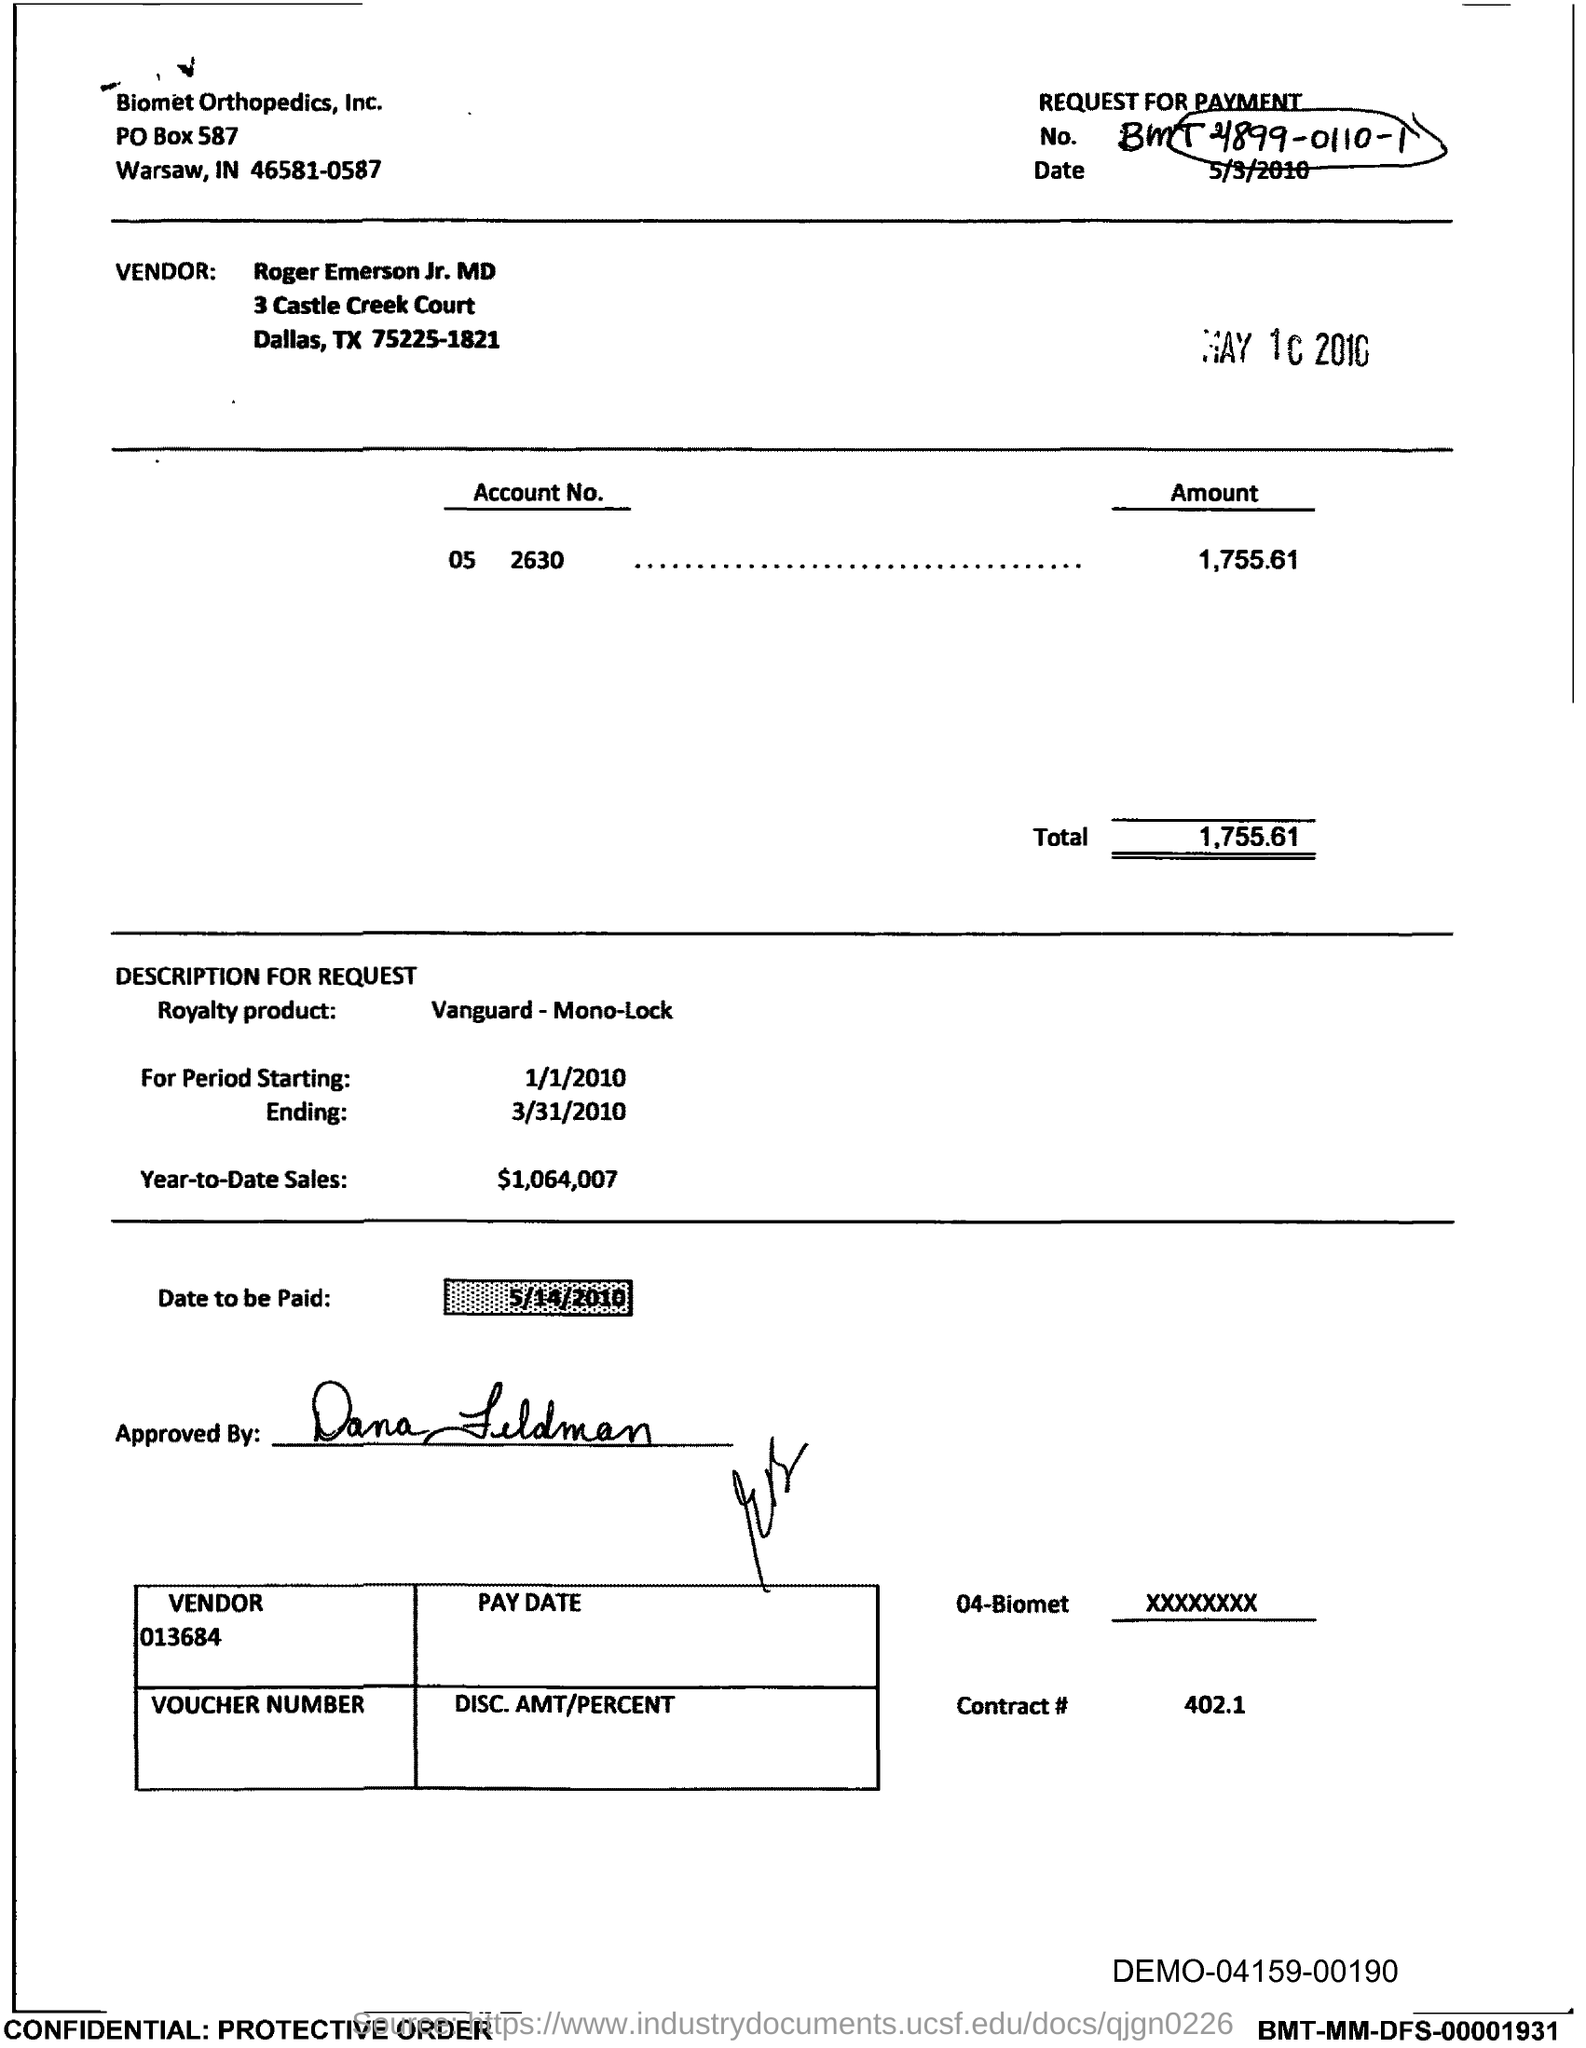Draw attention to some important aspects in this diagram. The total is 1,755.61 dollars. The contract number is 402.1. The PO Box number mentioned in the document is 587. 